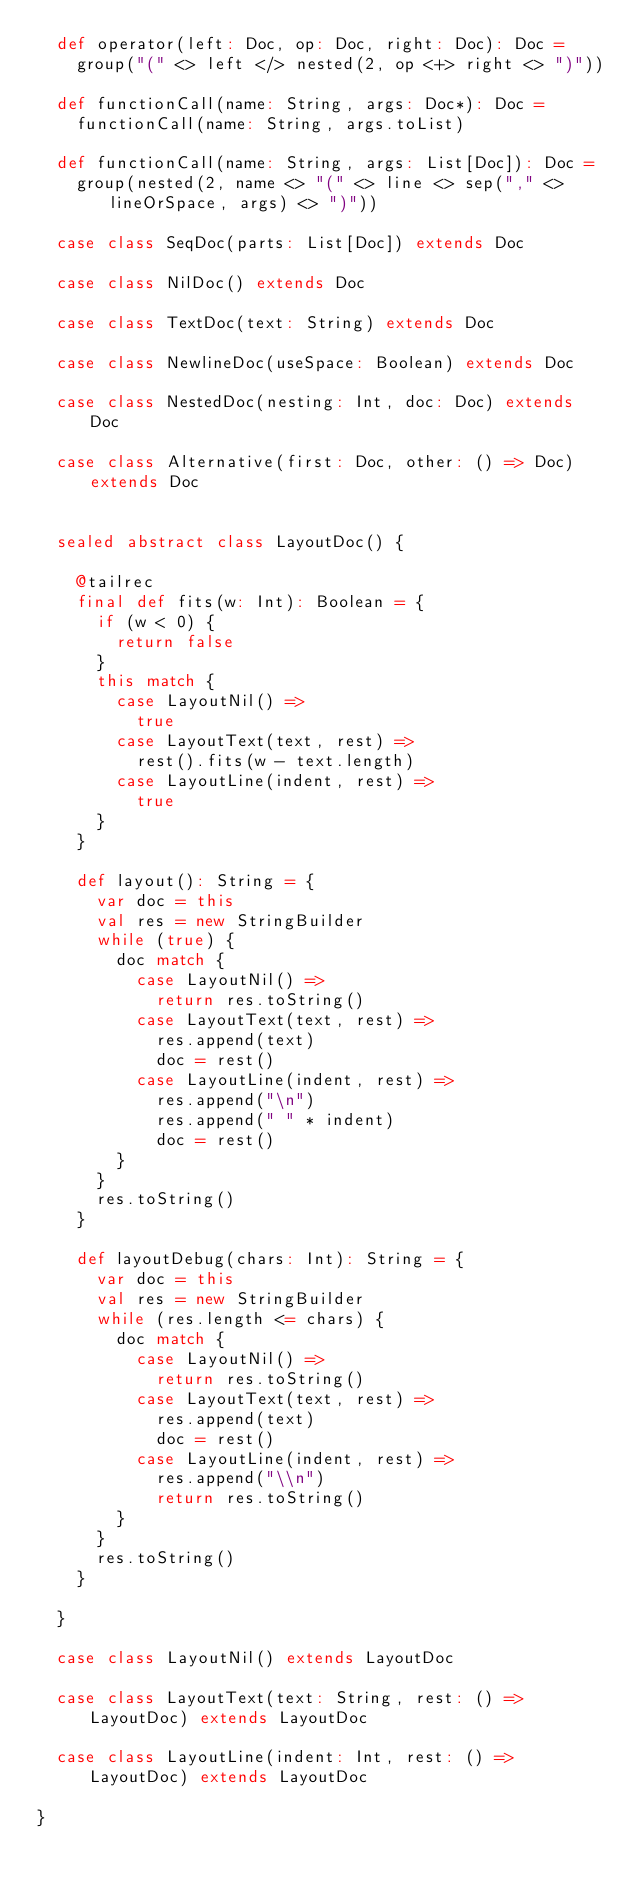Convert code to text. <code><loc_0><loc_0><loc_500><loc_500><_Scala_>  def operator(left: Doc, op: Doc, right: Doc): Doc =
    group("(" <> left </> nested(2, op <+> right <> ")"))

  def functionCall(name: String, args: Doc*): Doc =
    functionCall(name: String, args.toList)

  def functionCall(name: String, args: List[Doc]): Doc =
    group(nested(2, name <> "(" <> line <> sep("," <> lineOrSpace, args) <> ")"))

  case class SeqDoc(parts: List[Doc]) extends Doc

  case class NilDoc() extends Doc

  case class TextDoc(text: String) extends Doc

  case class NewlineDoc(useSpace: Boolean) extends Doc

  case class NestedDoc(nesting: Int, doc: Doc) extends Doc

  case class Alternative(first: Doc, other: () => Doc) extends Doc


  sealed abstract class LayoutDoc() {

    @tailrec
    final def fits(w: Int): Boolean = {
      if (w < 0) {
        return false
      }
      this match {
        case LayoutNil() =>
          true
        case LayoutText(text, rest) =>
          rest().fits(w - text.length)
        case LayoutLine(indent, rest) =>
          true
      }
    }

    def layout(): String = {
      var doc = this
      val res = new StringBuilder
      while (true) {
        doc match {
          case LayoutNil() =>
            return res.toString()
          case LayoutText(text, rest) =>
            res.append(text)
            doc = rest()
          case LayoutLine(indent, rest) =>
            res.append("\n")
            res.append(" " * indent)
            doc = rest()
        }
      }
      res.toString()
    }

    def layoutDebug(chars: Int): String = {
      var doc = this
      val res = new StringBuilder
      while (res.length <= chars) {
        doc match {
          case LayoutNil() =>
            return res.toString()
          case LayoutText(text, rest) =>
            res.append(text)
            doc = rest()
          case LayoutLine(indent, rest) =>
            res.append("\\n")
            return res.toString()
        }
      }
      res.toString()
    }

  }

  case class LayoutNil() extends LayoutDoc

  case class LayoutText(text: String, rest: () => LayoutDoc) extends LayoutDoc

  case class LayoutLine(indent: Int, rest: () => LayoutDoc) extends LayoutDoc

}
</code> 